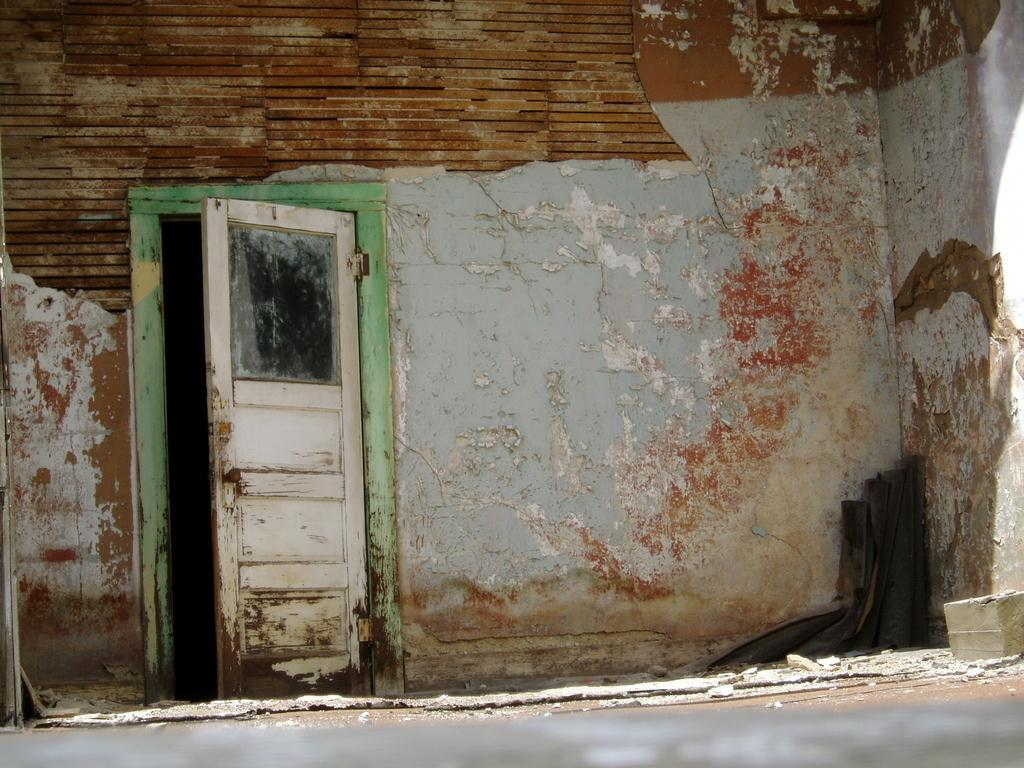What type of pathway is present in the image? There is a road in the image. What type of entrance can be seen in the image? There is a door in the image. What architectural feature is visible in the background of the image? There is a wall visible in the background of the image. What type of chess piece is located on the wall in the image? There is no chess piece present on the wall in the image. What type of writing can be seen on the door in the image? There is no writing visible on the door in the image. 